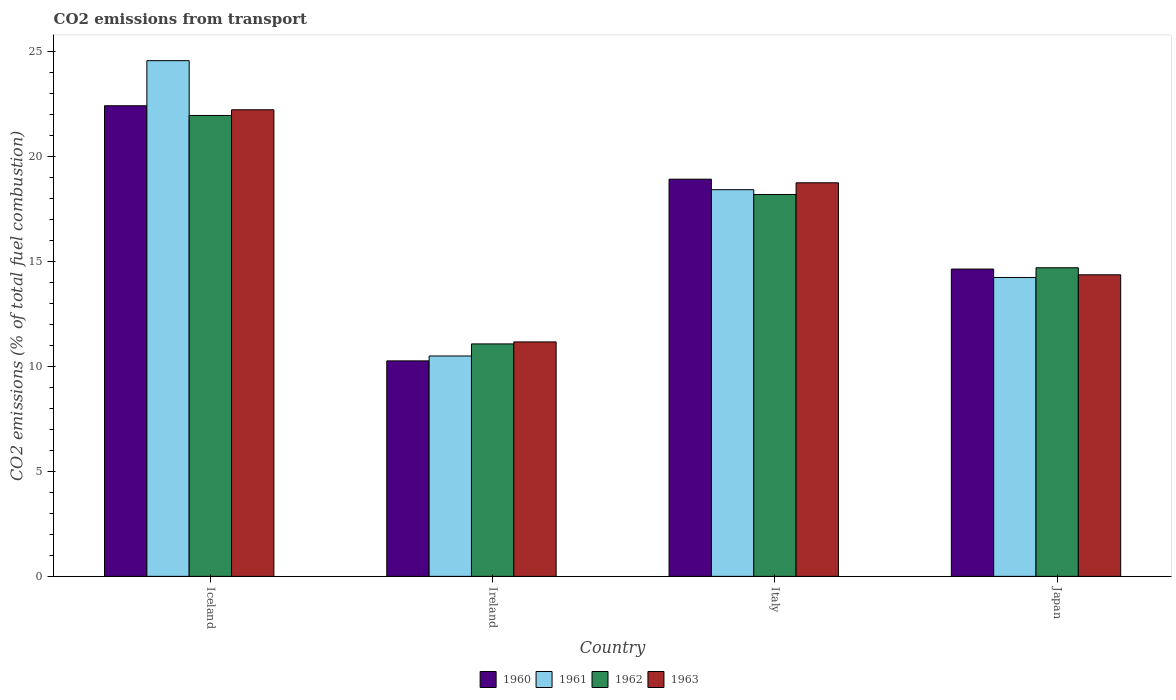What is the label of the 2nd group of bars from the left?
Your response must be concise. Ireland. In how many cases, is the number of bars for a given country not equal to the number of legend labels?
Offer a terse response. 0. What is the total CO2 emitted in 1963 in Iceland?
Keep it short and to the point. 22.22. Across all countries, what is the maximum total CO2 emitted in 1960?
Keep it short and to the point. 22.41. Across all countries, what is the minimum total CO2 emitted in 1962?
Offer a very short reply. 11.07. In which country was the total CO2 emitted in 1963 minimum?
Your response must be concise. Ireland. What is the total total CO2 emitted in 1962 in the graph?
Offer a terse response. 65.91. What is the difference between the total CO2 emitted in 1961 in Iceland and that in Japan?
Your answer should be compact. 10.33. What is the difference between the total CO2 emitted in 1961 in Iceland and the total CO2 emitted in 1960 in Japan?
Provide a short and direct response. 9.93. What is the average total CO2 emitted in 1962 per country?
Your response must be concise. 16.48. What is the difference between the total CO2 emitted of/in 1960 and total CO2 emitted of/in 1961 in Japan?
Your response must be concise. 0.4. What is the ratio of the total CO2 emitted in 1960 in Iceland to that in Ireland?
Make the answer very short. 2.18. What is the difference between the highest and the second highest total CO2 emitted in 1961?
Your answer should be very brief. 6.15. What is the difference between the highest and the lowest total CO2 emitted in 1960?
Keep it short and to the point. 12.15. Is it the case that in every country, the sum of the total CO2 emitted in 1960 and total CO2 emitted in 1962 is greater than the sum of total CO2 emitted in 1963 and total CO2 emitted in 1961?
Offer a terse response. No. What does the 4th bar from the left in Iceland represents?
Keep it short and to the point. 1963. How many bars are there?
Give a very brief answer. 16. What is the difference between two consecutive major ticks on the Y-axis?
Offer a terse response. 5. Where does the legend appear in the graph?
Your answer should be very brief. Bottom center. How many legend labels are there?
Make the answer very short. 4. How are the legend labels stacked?
Your answer should be very brief. Horizontal. What is the title of the graph?
Offer a very short reply. CO2 emissions from transport. What is the label or title of the X-axis?
Offer a terse response. Country. What is the label or title of the Y-axis?
Offer a terse response. CO2 emissions (% of total fuel combustion). What is the CO2 emissions (% of total fuel combustion) in 1960 in Iceland?
Your answer should be compact. 22.41. What is the CO2 emissions (% of total fuel combustion) of 1961 in Iceland?
Provide a short and direct response. 24.56. What is the CO2 emissions (% of total fuel combustion) in 1962 in Iceland?
Your response must be concise. 21.95. What is the CO2 emissions (% of total fuel combustion) of 1963 in Iceland?
Your answer should be compact. 22.22. What is the CO2 emissions (% of total fuel combustion) in 1960 in Ireland?
Your answer should be very brief. 10.26. What is the CO2 emissions (% of total fuel combustion) in 1961 in Ireland?
Your answer should be compact. 10.5. What is the CO2 emissions (% of total fuel combustion) of 1962 in Ireland?
Offer a terse response. 11.07. What is the CO2 emissions (% of total fuel combustion) of 1963 in Ireland?
Provide a succinct answer. 11.17. What is the CO2 emissions (% of total fuel combustion) of 1960 in Italy?
Give a very brief answer. 18.92. What is the CO2 emissions (% of total fuel combustion) in 1961 in Italy?
Provide a succinct answer. 18.42. What is the CO2 emissions (% of total fuel combustion) in 1962 in Italy?
Offer a very short reply. 18.19. What is the CO2 emissions (% of total fuel combustion) of 1963 in Italy?
Offer a terse response. 18.74. What is the CO2 emissions (% of total fuel combustion) of 1960 in Japan?
Keep it short and to the point. 14.64. What is the CO2 emissions (% of total fuel combustion) of 1961 in Japan?
Give a very brief answer. 14.23. What is the CO2 emissions (% of total fuel combustion) in 1962 in Japan?
Give a very brief answer. 14.7. What is the CO2 emissions (% of total fuel combustion) in 1963 in Japan?
Provide a succinct answer. 14.36. Across all countries, what is the maximum CO2 emissions (% of total fuel combustion) in 1960?
Provide a short and direct response. 22.41. Across all countries, what is the maximum CO2 emissions (% of total fuel combustion) of 1961?
Offer a terse response. 24.56. Across all countries, what is the maximum CO2 emissions (% of total fuel combustion) in 1962?
Your answer should be very brief. 21.95. Across all countries, what is the maximum CO2 emissions (% of total fuel combustion) in 1963?
Your answer should be compact. 22.22. Across all countries, what is the minimum CO2 emissions (% of total fuel combustion) of 1960?
Ensure brevity in your answer.  10.26. Across all countries, what is the minimum CO2 emissions (% of total fuel combustion) of 1961?
Provide a succinct answer. 10.5. Across all countries, what is the minimum CO2 emissions (% of total fuel combustion) in 1962?
Provide a succinct answer. 11.07. Across all countries, what is the minimum CO2 emissions (% of total fuel combustion) in 1963?
Make the answer very short. 11.17. What is the total CO2 emissions (% of total fuel combustion) of 1960 in the graph?
Offer a very short reply. 66.23. What is the total CO2 emissions (% of total fuel combustion) in 1961 in the graph?
Provide a short and direct response. 67.71. What is the total CO2 emissions (% of total fuel combustion) of 1962 in the graph?
Your answer should be compact. 65.91. What is the total CO2 emissions (% of total fuel combustion) of 1963 in the graph?
Your response must be concise. 66.5. What is the difference between the CO2 emissions (% of total fuel combustion) in 1960 in Iceland and that in Ireland?
Offer a terse response. 12.15. What is the difference between the CO2 emissions (% of total fuel combustion) of 1961 in Iceland and that in Ireland?
Keep it short and to the point. 14.07. What is the difference between the CO2 emissions (% of total fuel combustion) of 1962 in Iceland and that in Ireland?
Provide a short and direct response. 10.88. What is the difference between the CO2 emissions (% of total fuel combustion) in 1963 in Iceland and that in Ireland?
Your answer should be compact. 11.06. What is the difference between the CO2 emissions (% of total fuel combustion) of 1960 in Iceland and that in Italy?
Give a very brief answer. 3.5. What is the difference between the CO2 emissions (% of total fuel combustion) of 1961 in Iceland and that in Italy?
Give a very brief answer. 6.15. What is the difference between the CO2 emissions (% of total fuel combustion) of 1962 in Iceland and that in Italy?
Your response must be concise. 3.76. What is the difference between the CO2 emissions (% of total fuel combustion) of 1963 in Iceland and that in Italy?
Give a very brief answer. 3.48. What is the difference between the CO2 emissions (% of total fuel combustion) of 1960 in Iceland and that in Japan?
Make the answer very short. 7.78. What is the difference between the CO2 emissions (% of total fuel combustion) of 1961 in Iceland and that in Japan?
Give a very brief answer. 10.33. What is the difference between the CO2 emissions (% of total fuel combustion) of 1962 in Iceland and that in Japan?
Ensure brevity in your answer.  7.25. What is the difference between the CO2 emissions (% of total fuel combustion) in 1963 in Iceland and that in Japan?
Offer a terse response. 7.86. What is the difference between the CO2 emissions (% of total fuel combustion) in 1960 in Ireland and that in Italy?
Provide a short and direct response. -8.65. What is the difference between the CO2 emissions (% of total fuel combustion) in 1961 in Ireland and that in Italy?
Offer a terse response. -7.92. What is the difference between the CO2 emissions (% of total fuel combustion) of 1962 in Ireland and that in Italy?
Offer a terse response. -7.12. What is the difference between the CO2 emissions (% of total fuel combustion) in 1963 in Ireland and that in Italy?
Ensure brevity in your answer.  -7.58. What is the difference between the CO2 emissions (% of total fuel combustion) of 1960 in Ireland and that in Japan?
Give a very brief answer. -4.37. What is the difference between the CO2 emissions (% of total fuel combustion) in 1961 in Ireland and that in Japan?
Provide a short and direct response. -3.74. What is the difference between the CO2 emissions (% of total fuel combustion) of 1962 in Ireland and that in Japan?
Offer a very short reply. -3.63. What is the difference between the CO2 emissions (% of total fuel combustion) of 1963 in Ireland and that in Japan?
Ensure brevity in your answer.  -3.2. What is the difference between the CO2 emissions (% of total fuel combustion) of 1960 in Italy and that in Japan?
Your answer should be very brief. 4.28. What is the difference between the CO2 emissions (% of total fuel combustion) in 1961 in Italy and that in Japan?
Make the answer very short. 4.18. What is the difference between the CO2 emissions (% of total fuel combustion) of 1962 in Italy and that in Japan?
Provide a succinct answer. 3.49. What is the difference between the CO2 emissions (% of total fuel combustion) in 1963 in Italy and that in Japan?
Provide a succinct answer. 4.38. What is the difference between the CO2 emissions (% of total fuel combustion) of 1960 in Iceland and the CO2 emissions (% of total fuel combustion) of 1961 in Ireland?
Provide a short and direct response. 11.92. What is the difference between the CO2 emissions (% of total fuel combustion) in 1960 in Iceland and the CO2 emissions (% of total fuel combustion) in 1962 in Ireland?
Make the answer very short. 11.34. What is the difference between the CO2 emissions (% of total fuel combustion) in 1960 in Iceland and the CO2 emissions (% of total fuel combustion) in 1963 in Ireland?
Make the answer very short. 11.25. What is the difference between the CO2 emissions (% of total fuel combustion) of 1961 in Iceland and the CO2 emissions (% of total fuel combustion) of 1962 in Ireland?
Provide a short and direct response. 13.49. What is the difference between the CO2 emissions (% of total fuel combustion) of 1961 in Iceland and the CO2 emissions (% of total fuel combustion) of 1963 in Ireland?
Offer a very short reply. 13.4. What is the difference between the CO2 emissions (% of total fuel combustion) in 1962 in Iceland and the CO2 emissions (% of total fuel combustion) in 1963 in Ireland?
Your answer should be compact. 10.79. What is the difference between the CO2 emissions (% of total fuel combustion) in 1960 in Iceland and the CO2 emissions (% of total fuel combustion) in 1961 in Italy?
Your response must be concise. 4. What is the difference between the CO2 emissions (% of total fuel combustion) of 1960 in Iceland and the CO2 emissions (% of total fuel combustion) of 1962 in Italy?
Offer a very short reply. 4.23. What is the difference between the CO2 emissions (% of total fuel combustion) in 1960 in Iceland and the CO2 emissions (% of total fuel combustion) in 1963 in Italy?
Offer a very short reply. 3.67. What is the difference between the CO2 emissions (% of total fuel combustion) of 1961 in Iceland and the CO2 emissions (% of total fuel combustion) of 1962 in Italy?
Make the answer very short. 6.37. What is the difference between the CO2 emissions (% of total fuel combustion) in 1961 in Iceland and the CO2 emissions (% of total fuel combustion) in 1963 in Italy?
Your response must be concise. 5.82. What is the difference between the CO2 emissions (% of total fuel combustion) of 1962 in Iceland and the CO2 emissions (% of total fuel combustion) of 1963 in Italy?
Offer a very short reply. 3.21. What is the difference between the CO2 emissions (% of total fuel combustion) in 1960 in Iceland and the CO2 emissions (% of total fuel combustion) in 1961 in Japan?
Your response must be concise. 8.18. What is the difference between the CO2 emissions (% of total fuel combustion) in 1960 in Iceland and the CO2 emissions (% of total fuel combustion) in 1962 in Japan?
Make the answer very short. 7.72. What is the difference between the CO2 emissions (% of total fuel combustion) of 1960 in Iceland and the CO2 emissions (% of total fuel combustion) of 1963 in Japan?
Your response must be concise. 8.05. What is the difference between the CO2 emissions (% of total fuel combustion) in 1961 in Iceland and the CO2 emissions (% of total fuel combustion) in 1962 in Japan?
Your response must be concise. 9.86. What is the difference between the CO2 emissions (% of total fuel combustion) in 1961 in Iceland and the CO2 emissions (% of total fuel combustion) in 1963 in Japan?
Your response must be concise. 10.2. What is the difference between the CO2 emissions (% of total fuel combustion) in 1962 in Iceland and the CO2 emissions (% of total fuel combustion) in 1963 in Japan?
Your response must be concise. 7.59. What is the difference between the CO2 emissions (% of total fuel combustion) in 1960 in Ireland and the CO2 emissions (% of total fuel combustion) in 1961 in Italy?
Make the answer very short. -8.15. What is the difference between the CO2 emissions (% of total fuel combustion) of 1960 in Ireland and the CO2 emissions (% of total fuel combustion) of 1962 in Italy?
Provide a succinct answer. -7.92. What is the difference between the CO2 emissions (% of total fuel combustion) in 1960 in Ireland and the CO2 emissions (% of total fuel combustion) in 1963 in Italy?
Your answer should be very brief. -8.48. What is the difference between the CO2 emissions (% of total fuel combustion) in 1961 in Ireland and the CO2 emissions (% of total fuel combustion) in 1962 in Italy?
Ensure brevity in your answer.  -7.69. What is the difference between the CO2 emissions (% of total fuel combustion) in 1961 in Ireland and the CO2 emissions (% of total fuel combustion) in 1963 in Italy?
Offer a very short reply. -8.25. What is the difference between the CO2 emissions (% of total fuel combustion) of 1962 in Ireland and the CO2 emissions (% of total fuel combustion) of 1963 in Italy?
Ensure brevity in your answer.  -7.67. What is the difference between the CO2 emissions (% of total fuel combustion) of 1960 in Ireland and the CO2 emissions (% of total fuel combustion) of 1961 in Japan?
Give a very brief answer. -3.97. What is the difference between the CO2 emissions (% of total fuel combustion) of 1960 in Ireland and the CO2 emissions (% of total fuel combustion) of 1962 in Japan?
Keep it short and to the point. -4.44. What is the difference between the CO2 emissions (% of total fuel combustion) in 1960 in Ireland and the CO2 emissions (% of total fuel combustion) in 1963 in Japan?
Your answer should be very brief. -4.1. What is the difference between the CO2 emissions (% of total fuel combustion) of 1961 in Ireland and the CO2 emissions (% of total fuel combustion) of 1962 in Japan?
Give a very brief answer. -4.2. What is the difference between the CO2 emissions (% of total fuel combustion) of 1961 in Ireland and the CO2 emissions (% of total fuel combustion) of 1963 in Japan?
Keep it short and to the point. -3.87. What is the difference between the CO2 emissions (% of total fuel combustion) of 1962 in Ireland and the CO2 emissions (% of total fuel combustion) of 1963 in Japan?
Keep it short and to the point. -3.29. What is the difference between the CO2 emissions (% of total fuel combustion) in 1960 in Italy and the CO2 emissions (% of total fuel combustion) in 1961 in Japan?
Ensure brevity in your answer.  4.68. What is the difference between the CO2 emissions (% of total fuel combustion) of 1960 in Italy and the CO2 emissions (% of total fuel combustion) of 1962 in Japan?
Offer a terse response. 4.22. What is the difference between the CO2 emissions (% of total fuel combustion) in 1960 in Italy and the CO2 emissions (% of total fuel combustion) in 1963 in Japan?
Keep it short and to the point. 4.55. What is the difference between the CO2 emissions (% of total fuel combustion) of 1961 in Italy and the CO2 emissions (% of total fuel combustion) of 1962 in Japan?
Make the answer very short. 3.72. What is the difference between the CO2 emissions (% of total fuel combustion) of 1961 in Italy and the CO2 emissions (% of total fuel combustion) of 1963 in Japan?
Your response must be concise. 4.05. What is the difference between the CO2 emissions (% of total fuel combustion) of 1962 in Italy and the CO2 emissions (% of total fuel combustion) of 1963 in Japan?
Your answer should be very brief. 3.82. What is the average CO2 emissions (% of total fuel combustion) of 1960 per country?
Your answer should be compact. 16.56. What is the average CO2 emissions (% of total fuel combustion) of 1961 per country?
Keep it short and to the point. 16.93. What is the average CO2 emissions (% of total fuel combustion) of 1962 per country?
Provide a succinct answer. 16.48. What is the average CO2 emissions (% of total fuel combustion) in 1963 per country?
Your answer should be very brief. 16.62. What is the difference between the CO2 emissions (% of total fuel combustion) in 1960 and CO2 emissions (% of total fuel combustion) in 1961 in Iceland?
Provide a succinct answer. -2.15. What is the difference between the CO2 emissions (% of total fuel combustion) in 1960 and CO2 emissions (% of total fuel combustion) in 1962 in Iceland?
Give a very brief answer. 0.46. What is the difference between the CO2 emissions (% of total fuel combustion) in 1960 and CO2 emissions (% of total fuel combustion) in 1963 in Iceland?
Offer a very short reply. 0.19. What is the difference between the CO2 emissions (% of total fuel combustion) in 1961 and CO2 emissions (% of total fuel combustion) in 1962 in Iceland?
Your answer should be very brief. 2.61. What is the difference between the CO2 emissions (% of total fuel combustion) of 1961 and CO2 emissions (% of total fuel combustion) of 1963 in Iceland?
Keep it short and to the point. 2.34. What is the difference between the CO2 emissions (% of total fuel combustion) of 1962 and CO2 emissions (% of total fuel combustion) of 1963 in Iceland?
Keep it short and to the point. -0.27. What is the difference between the CO2 emissions (% of total fuel combustion) of 1960 and CO2 emissions (% of total fuel combustion) of 1961 in Ireland?
Offer a terse response. -0.23. What is the difference between the CO2 emissions (% of total fuel combustion) of 1960 and CO2 emissions (% of total fuel combustion) of 1962 in Ireland?
Offer a very short reply. -0.81. What is the difference between the CO2 emissions (% of total fuel combustion) in 1960 and CO2 emissions (% of total fuel combustion) in 1963 in Ireland?
Give a very brief answer. -0.9. What is the difference between the CO2 emissions (% of total fuel combustion) of 1961 and CO2 emissions (% of total fuel combustion) of 1962 in Ireland?
Keep it short and to the point. -0.58. What is the difference between the CO2 emissions (% of total fuel combustion) of 1961 and CO2 emissions (% of total fuel combustion) of 1963 in Ireland?
Keep it short and to the point. -0.67. What is the difference between the CO2 emissions (% of total fuel combustion) of 1962 and CO2 emissions (% of total fuel combustion) of 1963 in Ireland?
Your answer should be compact. -0.09. What is the difference between the CO2 emissions (% of total fuel combustion) in 1960 and CO2 emissions (% of total fuel combustion) in 1961 in Italy?
Ensure brevity in your answer.  0.5. What is the difference between the CO2 emissions (% of total fuel combustion) in 1960 and CO2 emissions (% of total fuel combustion) in 1962 in Italy?
Make the answer very short. 0.73. What is the difference between the CO2 emissions (% of total fuel combustion) of 1960 and CO2 emissions (% of total fuel combustion) of 1963 in Italy?
Offer a terse response. 0.17. What is the difference between the CO2 emissions (% of total fuel combustion) in 1961 and CO2 emissions (% of total fuel combustion) in 1962 in Italy?
Give a very brief answer. 0.23. What is the difference between the CO2 emissions (% of total fuel combustion) in 1961 and CO2 emissions (% of total fuel combustion) in 1963 in Italy?
Make the answer very short. -0.33. What is the difference between the CO2 emissions (% of total fuel combustion) in 1962 and CO2 emissions (% of total fuel combustion) in 1963 in Italy?
Offer a very short reply. -0.56. What is the difference between the CO2 emissions (% of total fuel combustion) of 1960 and CO2 emissions (% of total fuel combustion) of 1961 in Japan?
Give a very brief answer. 0.4. What is the difference between the CO2 emissions (% of total fuel combustion) in 1960 and CO2 emissions (% of total fuel combustion) in 1962 in Japan?
Your response must be concise. -0.06. What is the difference between the CO2 emissions (% of total fuel combustion) in 1960 and CO2 emissions (% of total fuel combustion) in 1963 in Japan?
Provide a succinct answer. 0.27. What is the difference between the CO2 emissions (% of total fuel combustion) in 1961 and CO2 emissions (% of total fuel combustion) in 1962 in Japan?
Offer a terse response. -0.46. What is the difference between the CO2 emissions (% of total fuel combustion) of 1961 and CO2 emissions (% of total fuel combustion) of 1963 in Japan?
Provide a succinct answer. -0.13. What is the difference between the CO2 emissions (% of total fuel combustion) in 1962 and CO2 emissions (% of total fuel combustion) in 1963 in Japan?
Your answer should be compact. 0.33. What is the ratio of the CO2 emissions (% of total fuel combustion) in 1960 in Iceland to that in Ireland?
Offer a terse response. 2.18. What is the ratio of the CO2 emissions (% of total fuel combustion) in 1961 in Iceland to that in Ireland?
Offer a terse response. 2.34. What is the ratio of the CO2 emissions (% of total fuel combustion) in 1962 in Iceland to that in Ireland?
Your answer should be compact. 1.98. What is the ratio of the CO2 emissions (% of total fuel combustion) of 1963 in Iceland to that in Ireland?
Your answer should be compact. 1.99. What is the ratio of the CO2 emissions (% of total fuel combustion) of 1960 in Iceland to that in Italy?
Make the answer very short. 1.18. What is the ratio of the CO2 emissions (% of total fuel combustion) in 1961 in Iceland to that in Italy?
Ensure brevity in your answer.  1.33. What is the ratio of the CO2 emissions (% of total fuel combustion) in 1962 in Iceland to that in Italy?
Provide a short and direct response. 1.21. What is the ratio of the CO2 emissions (% of total fuel combustion) of 1963 in Iceland to that in Italy?
Your answer should be compact. 1.19. What is the ratio of the CO2 emissions (% of total fuel combustion) of 1960 in Iceland to that in Japan?
Ensure brevity in your answer.  1.53. What is the ratio of the CO2 emissions (% of total fuel combustion) of 1961 in Iceland to that in Japan?
Ensure brevity in your answer.  1.73. What is the ratio of the CO2 emissions (% of total fuel combustion) in 1962 in Iceland to that in Japan?
Keep it short and to the point. 1.49. What is the ratio of the CO2 emissions (% of total fuel combustion) in 1963 in Iceland to that in Japan?
Keep it short and to the point. 1.55. What is the ratio of the CO2 emissions (% of total fuel combustion) of 1960 in Ireland to that in Italy?
Make the answer very short. 0.54. What is the ratio of the CO2 emissions (% of total fuel combustion) in 1961 in Ireland to that in Italy?
Your answer should be very brief. 0.57. What is the ratio of the CO2 emissions (% of total fuel combustion) of 1962 in Ireland to that in Italy?
Your response must be concise. 0.61. What is the ratio of the CO2 emissions (% of total fuel combustion) in 1963 in Ireland to that in Italy?
Ensure brevity in your answer.  0.6. What is the ratio of the CO2 emissions (% of total fuel combustion) in 1960 in Ireland to that in Japan?
Your response must be concise. 0.7. What is the ratio of the CO2 emissions (% of total fuel combustion) in 1961 in Ireland to that in Japan?
Your answer should be very brief. 0.74. What is the ratio of the CO2 emissions (% of total fuel combustion) of 1962 in Ireland to that in Japan?
Offer a very short reply. 0.75. What is the ratio of the CO2 emissions (% of total fuel combustion) of 1963 in Ireland to that in Japan?
Provide a succinct answer. 0.78. What is the ratio of the CO2 emissions (% of total fuel combustion) in 1960 in Italy to that in Japan?
Offer a terse response. 1.29. What is the ratio of the CO2 emissions (% of total fuel combustion) in 1961 in Italy to that in Japan?
Offer a very short reply. 1.29. What is the ratio of the CO2 emissions (% of total fuel combustion) of 1962 in Italy to that in Japan?
Give a very brief answer. 1.24. What is the ratio of the CO2 emissions (% of total fuel combustion) in 1963 in Italy to that in Japan?
Your answer should be compact. 1.31. What is the difference between the highest and the second highest CO2 emissions (% of total fuel combustion) in 1960?
Your answer should be compact. 3.5. What is the difference between the highest and the second highest CO2 emissions (% of total fuel combustion) of 1961?
Your answer should be compact. 6.15. What is the difference between the highest and the second highest CO2 emissions (% of total fuel combustion) of 1962?
Make the answer very short. 3.76. What is the difference between the highest and the second highest CO2 emissions (% of total fuel combustion) of 1963?
Your answer should be compact. 3.48. What is the difference between the highest and the lowest CO2 emissions (% of total fuel combustion) in 1960?
Your answer should be compact. 12.15. What is the difference between the highest and the lowest CO2 emissions (% of total fuel combustion) of 1961?
Your response must be concise. 14.07. What is the difference between the highest and the lowest CO2 emissions (% of total fuel combustion) in 1962?
Make the answer very short. 10.88. What is the difference between the highest and the lowest CO2 emissions (% of total fuel combustion) of 1963?
Offer a very short reply. 11.06. 